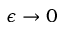Convert formula to latex. <formula><loc_0><loc_0><loc_500><loc_500>\epsilon \to 0</formula> 